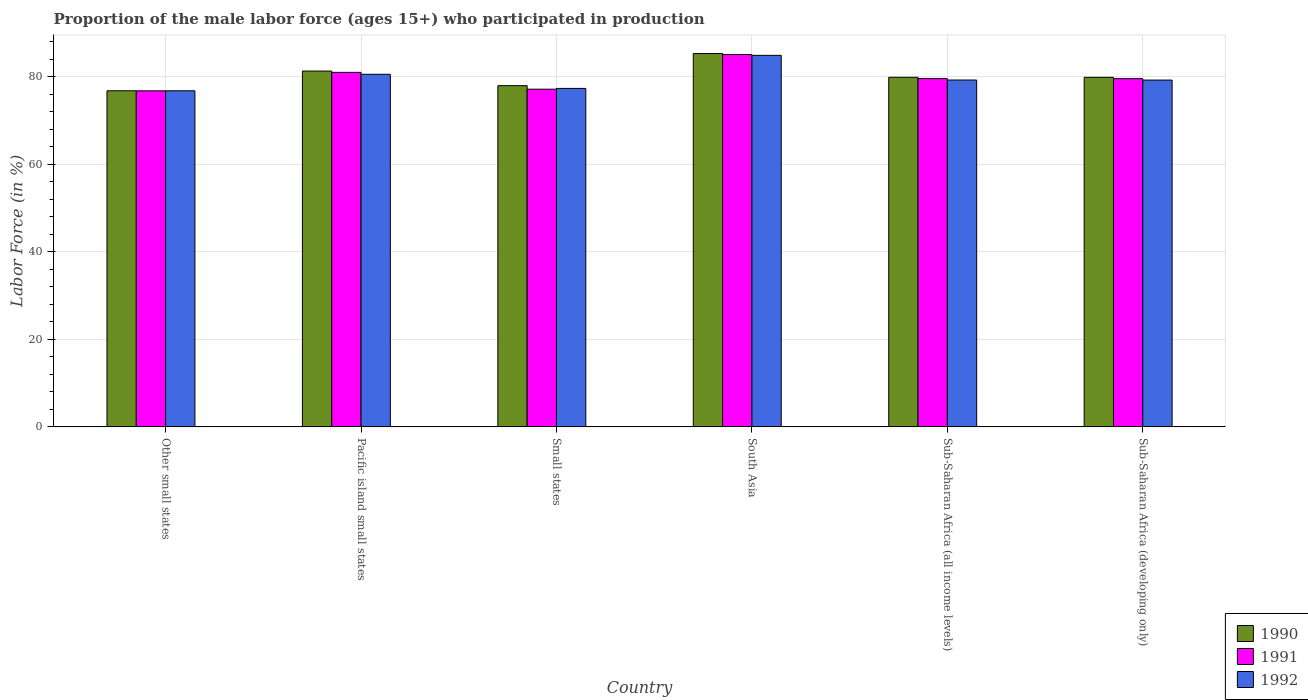How many different coloured bars are there?
Your response must be concise. 3. How many bars are there on the 1st tick from the left?
Your answer should be compact. 3. What is the label of the 3rd group of bars from the left?
Your answer should be very brief. Small states. What is the proportion of the male labor force who participated in production in 1992 in South Asia?
Your answer should be compact. 84.88. Across all countries, what is the maximum proportion of the male labor force who participated in production in 1990?
Keep it short and to the point. 85.3. Across all countries, what is the minimum proportion of the male labor force who participated in production in 1991?
Your answer should be compact. 76.78. In which country was the proportion of the male labor force who participated in production in 1991 maximum?
Give a very brief answer. South Asia. In which country was the proportion of the male labor force who participated in production in 1990 minimum?
Offer a terse response. Other small states. What is the total proportion of the male labor force who participated in production in 1991 in the graph?
Make the answer very short. 479.13. What is the difference between the proportion of the male labor force who participated in production in 1990 in Other small states and that in South Asia?
Provide a short and direct response. -8.51. What is the difference between the proportion of the male labor force who participated in production in 1990 in Other small states and the proportion of the male labor force who participated in production in 1992 in Sub-Saharan Africa (developing only)?
Ensure brevity in your answer.  -2.44. What is the average proportion of the male labor force who participated in production in 1990 per country?
Provide a succinct answer. 80.18. What is the difference between the proportion of the male labor force who participated in production of/in 1991 and proportion of the male labor force who participated in production of/in 1992 in Sub-Saharan Africa (all income levels)?
Provide a short and direct response. 0.32. What is the ratio of the proportion of the male labor force who participated in production in 1990 in South Asia to that in Sub-Saharan Africa (all income levels)?
Provide a short and direct response. 1.07. What is the difference between the highest and the second highest proportion of the male labor force who participated in production in 1991?
Make the answer very short. -4.07. What is the difference between the highest and the lowest proportion of the male labor force who participated in production in 1990?
Your answer should be compact. 8.51. In how many countries, is the proportion of the male labor force who participated in production in 1990 greater than the average proportion of the male labor force who participated in production in 1990 taken over all countries?
Provide a succinct answer. 2. What does the 2nd bar from the left in Sub-Saharan Africa (developing only) represents?
Keep it short and to the point. 1991. Is it the case that in every country, the sum of the proportion of the male labor force who participated in production in 1990 and proportion of the male labor force who participated in production in 1992 is greater than the proportion of the male labor force who participated in production in 1991?
Your response must be concise. Yes. How many bars are there?
Give a very brief answer. 18. Are all the bars in the graph horizontal?
Provide a short and direct response. No. How many countries are there in the graph?
Your response must be concise. 6. Does the graph contain any zero values?
Offer a very short reply. No. Where does the legend appear in the graph?
Keep it short and to the point. Bottom right. How are the legend labels stacked?
Give a very brief answer. Vertical. What is the title of the graph?
Your response must be concise. Proportion of the male labor force (ages 15+) who participated in production. Does "2015" appear as one of the legend labels in the graph?
Offer a terse response. No. What is the label or title of the X-axis?
Ensure brevity in your answer.  Country. What is the Labor Force (in %) of 1990 in Other small states?
Offer a terse response. 76.79. What is the Labor Force (in %) in 1991 in Other small states?
Your answer should be very brief. 76.78. What is the Labor Force (in %) of 1992 in Other small states?
Give a very brief answer. 76.79. What is the Labor Force (in %) in 1990 in Pacific island small states?
Your response must be concise. 81.29. What is the Labor Force (in %) of 1991 in Pacific island small states?
Provide a short and direct response. 81. What is the Labor Force (in %) of 1992 in Pacific island small states?
Make the answer very short. 80.56. What is the Labor Force (in %) in 1990 in Small states?
Make the answer very short. 77.96. What is the Labor Force (in %) of 1991 in Small states?
Make the answer very short. 77.15. What is the Labor Force (in %) of 1992 in Small states?
Provide a short and direct response. 77.33. What is the Labor Force (in %) in 1990 in South Asia?
Your answer should be very brief. 85.3. What is the Labor Force (in %) of 1991 in South Asia?
Provide a succinct answer. 85.07. What is the Labor Force (in %) of 1992 in South Asia?
Provide a short and direct response. 84.88. What is the Labor Force (in %) in 1990 in Sub-Saharan Africa (all income levels)?
Keep it short and to the point. 79.87. What is the Labor Force (in %) in 1991 in Sub-Saharan Africa (all income levels)?
Make the answer very short. 79.57. What is the Labor Force (in %) of 1992 in Sub-Saharan Africa (all income levels)?
Ensure brevity in your answer.  79.25. What is the Labor Force (in %) of 1990 in Sub-Saharan Africa (developing only)?
Make the answer very short. 79.86. What is the Labor Force (in %) of 1991 in Sub-Saharan Africa (developing only)?
Your answer should be very brief. 79.56. What is the Labor Force (in %) in 1992 in Sub-Saharan Africa (developing only)?
Ensure brevity in your answer.  79.23. Across all countries, what is the maximum Labor Force (in %) of 1990?
Your answer should be very brief. 85.3. Across all countries, what is the maximum Labor Force (in %) in 1991?
Make the answer very short. 85.07. Across all countries, what is the maximum Labor Force (in %) of 1992?
Keep it short and to the point. 84.88. Across all countries, what is the minimum Labor Force (in %) of 1990?
Give a very brief answer. 76.79. Across all countries, what is the minimum Labor Force (in %) in 1991?
Make the answer very short. 76.78. Across all countries, what is the minimum Labor Force (in %) in 1992?
Give a very brief answer. 76.79. What is the total Labor Force (in %) in 1990 in the graph?
Offer a terse response. 481.07. What is the total Labor Force (in %) in 1991 in the graph?
Ensure brevity in your answer.  479.13. What is the total Labor Force (in %) of 1992 in the graph?
Your answer should be compact. 478.03. What is the difference between the Labor Force (in %) of 1990 in Other small states and that in Pacific island small states?
Give a very brief answer. -4.5. What is the difference between the Labor Force (in %) in 1991 in Other small states and that in Pacific island small states?
Your answer should be very brief. -4.23. What is the difference between the Labor Force (in %) of 1992 in Other small states and that in Pacific island small states?
Offer a very short reply. -3.77. What is the difference between the Labor Force (in %) of 1990 in Other small states and that in Small states?
Provide a short and direct response. -1.17. What is the difference between the Labor Force (in %) in 1991 in Other small states and that in Small states?
Ensure brevity in your answer.  -0.38. What is the difference between the Labor Force (in %) of 1992 in Other small states and that in Small states?
Your answer should be very brief. -0.54. What is the difference between the Labor Force (in %) in 1990 in Other small states and that in South Asia?
Your response must be concise. -8.51. What is the difference between the Labor Force (in %) of 1991 in Other small states and that in South Asia?
Make the answer very short. -8.3. What is the difference between the Labor Force (in %) in 1992 in Other small states and that in South Asia?
Provide a short and direct response. -8.1. What is the difference between the Labor Force (in %) in 1990 in Other small states and that in Sub-Saharan Africa (all income levels)?
Give a very brief answer. -3.08. What is the difference between the Labor Force (in %) in 1991 in Other small states and that in Sub-Saharan Africa (all income levels)?
Give a very brief answer. -2.79. What is the difference between the Labor Force (in %) of 1992 in Other small states and that in Sub-Saharan Africa (all income levels)?
Your answer should be compact. -2.46. What is the difference between the Labor Force (in %) of 1990 in Other small states and that in Sub-Saharan Africa (developing only)?
Keep it short and to the point. -3.07. What is the difference between the Labor Force (in %) in 1991 in Other small states and that in Sub-Saharan Africa (developing only)?
Give a very brief answer. -2.78. What is the difference between the Labor Force (in %) in 1992 in Other small states and that in Sub-Saharan Africa (developing only)?
Offer a terse response. -2.45. What is the difference between the Labor Force (in %) in 1990 in Pacific island small states and that in Small states?
Make the answer very short. 3.34. What is the difference between the Labor Force (in %) of 1991 in Pacific island small states and that in Small states?
Provide a short and direct response. 3.85. What is the difference between the Labor Force (in %) in 1992 in Pacific island small states and that in Small states?
Offer a very short reply. 3.23. What is the difference between the Labor Force (in %) of 1990 in Pacific island small states and that in South Asia?
Make the answer very short. -4. What is the difference between the Labor Force (in %) of 1991 in Pacific island small states and that in South Asia?
Provide a short and direct response. -4.07. What is the difference between the Labor Force (in %) of 1992 in Pacific island small states and that in South Asia?
Your answer should be compact. -4.33. What is the difference between the Labor Force (in %) in 1990 in Pacific island small states and that in Sub-Saharan Africa (all income levels)?
Offer a very short reply. 1.42. What is the difference between the Labor Force (in %) of 1991 in Pacific island small states and that in Sub-Saharan Africa (all income levels)?
Give a very brief answer. 1.43. What is the difference between the Labor Force (in %) of 1992 in Pacific island small states and that in Sub-Saharan Africa (all income levels)?
Offer a terse response. 1.31. What is the difference between the Labor Force (in %) of 1990 in Pacific island small states and that in Sub-Saharan Africa (developing only)?
Your answer should be very brief. 1.43. What is the difference between the Labor Force (in %) in 1991 in Pacific island small states and that in Sub-Saharan Africa (developing only)?
Your response must be concise. 1.44. What is the difference between the Labor Force (in %) in 1992 in Pacific island small states and that in Sub-Saharan Africa (developing only)?
Keep it short and to the point. 1.32. What is the difference between the Labor Force (in %) of 1990 in Small states and that in South Asia?
Make the answer very short. -7.34. What is the difference between the Labor Force (in %) in 1991 in Small states and that in South Asia?
Your answer should be compact. -7.92. What is the difference between the Labor Force (in %) of 1992 in Small states and that in South Asia?
Ensure brevity in your answer.  -7.56. What is the difference between the Labor Force (in %) in 1990 in Small states and that in Sub-Saharan Africa (all income levels)?
Ensure brevity in your answer.  -1.91. What is the difference between the Labor Force (in %) of 1991 in Small states and that in Sub-Saharan Africa (all income levels)?
Your answer should be very brief. -2.42. What is the difference between the Labor Force (in %) in 1992 in Small states and that in Sub-Saharan Africa (all income levels)?
Your answer should be very brief. -1.92. What is the difference between the Labor Force (in %) in 1990 in Small states and that in Sub-Saharan Africa (developing only)?
Your response must be concise. -1.9. What is the difference between the Labor Force (in %) in 1991 in Small states and that in Sub-Saharan Africa (developing only)?
Keep it short and to the point. -2.41. What is the difference between the Labor Force (in %) in 1992 in Small states and that in Sub-Saharan Africa (developing only)?
Provide a short and direct response. -1.91. What is the difference between the Labor Force (in %) in 1990 in South Asia and that in Sub-Saharan Africa (all income levels)?
Keep it short and to the point. 5.43. What is the difference between the Labor Force (in %) of 1991 in South Asia and that in Sub-Saharan Africa (all income levels)?
Your answer should be compact. 5.5. What is the difference between the Labor Force (in %) in 1992 in South Asia and that in Sub-Saharan Africa (all income levels)?
Offer a very short reply. 5.64. What is the difference between the Labor Force (in %) of 1990 in South Asia and that in Sub-Saharan Africa (developing only)?
Provide a succinct answer. 5.44. What is the difference between the Labor Force (in %) of 1991 in South Asia and that in Sub-Saharan Africa (developing only)?
Give a very brief answer. 5.51. What is the difference between the Labor Force (in %) in 1992 in South Asia and that in Sub-Saharan Africa (developing only)?
Make the answer very short. 5.65. What is the difference between the Labor Force (in %) in 1990 in Sub-Saharan Africa (all income levels) and that in Sub-Saharan Africa (developing only)?
Provide a short and direct response. 0.01. What is the difference between the Labor Force (in %) of 1991 in Sub-Saharan Africa (all income levels) and that in Sub-Saharan Africa (developing only)?
Keep it short and to the point. 0.01. What is the difference between the Labor Force (in %) in 1992 in Sub-Saharan Africa (all income levels) and that in Sub-Saharan Africa (developing only)?
Your answer should be compact. 0.01. What is the difference between the Labor Force (in %) in 1990 in Other small states and the Labor Force (in %) in 1991 in Pacific island small states?
Your answer should be compact. -4.21. What is the difference between the Labor Force (in %) in 1990 in Other small states and the Labor Force (in %) in 1992 in Pacific island small states?
Provide a short and direct response. -3.76. What is the difference between the Labor Force (in %) of 1991 in Other small states and the Labor Force (in %) of 1992 in Pacific island small states?
Your answer should be very brief. -3.78. What is the difference between the Labor Force (in %) of 1990 in Other small states and the Labor Force (in %) of 1991 in Small states?
Offer a terse response. -0.36. What is the difference between the Labor Force (in %) in 1990 in Other small states and the Labor Force (in %) in 1992 in Small states?
Offer a very short reply. -0.54. What is the difference between the Labor Force (in %) in 1991 in Other small states and the Labor Force (in %) in 1992 in Small states?
Ensure brevity in your answer.  -0.55. What is the difference between the Labor Force (in %) in 1990 in Other small states and the Labor Force (in %) in 1991 in South Asia?
Give a very brief answer. -8.28. What is the difference between the Labor Force (in %) in 1990 in Other small states and the Labor Force (in %) in 1992 in South Asia?
Give a very brief answer. -8.09. What is the difference between the Labor Force (in %) of 1991 in Other small states and the Labor Force (in %) of 1992 in South Asia?
Keep it short and to the point. -8.11. What is the difference between the Labor Force (in %) of 1990 in Other small states and the Labor Force (in %) of 1991 in Sub-Saharan Africa (all income levels)?
Provide a succinct answer. -2.78. What is the difference between the Labor Force (in %) in 1990 in Other small states and the Labor Force (in %) in 1992 in Sub-Saharan Africa (all income levels)?
Offer a very short reply. -2.45. What is the difference between the Labor Force (in %) in 1991 in Other small states and the Labor Force (in %) in 1992 in Sub-Saharan Africa (all income levels)?
Your answer should be very brief. -2.47. What is the difference between the Labor Force (in %) in 1990 in Other small states and the Labor Force (in %) in 1991 in Sub-Saharan Africa (developing only)?
Ensure brevity in your answer.  -2.77. What is the difference between the Labor Force (in %) of 1990 in Other small states and the Labor Force (in %) of 1992 in Sub-Saharan Africa (developing only)?
Your answer should be very brief. -2.44. What is the difference between the Labor Force (in %) in 1991 in Other small states and the Labor Force (in %) in 1992 in Sub-Saharan Africa (developing only)?
Provide a short and direct response. -2.46. What is the difference between the Labor Force (in %) of 1990 in Pacific island small states and the Labor Force (in %) of 1991 in Small states?
Keep it short and to the point. 4.14. What is the difference between the Labor Force (in %) of 1990 in Pacific island small states and the Labor Force (in %) of 1992 in Small states?
Offer a terse response. 3.97. What is the difference between the Labor Force (in %) of 1991 in Pacific island small states and the Labor Force (in %) of 1992 in Small states?
Your response must be concise. 3.67. What is the difference between the Labor Force (in %) in 1990 in Pacific island small states and the Labor Force (in %) in 1991 in South Asia?
Offer a terse response. -3.78. What is the difference between the Labor Force (in %) of 1990 in Pacific island small states and the Labor Force (in %) of 1992 in South Asia?
Your answer should be very brief. -3.59. What is the difference between the Labor Force (in %) of 1991 in Pacific island small states and the Labor Force (in %) of 1992 in South Asia?
Make the answer very short. -3.88. What is the difference between the Labor Force (in %) in 1990 in Pacific island small states and the Labor Force (in %) in 1991 in Sub-Saharan Africa (all income levels)?
Your answer should be compact. 1.72. What is the difference between the Labor Force (in %) in 1990 in Pacific island small states and the Labor Force (in %) in 1992 in Sub-Saharan Africa (all income levels)?
Offer a terse response. 2.05. What is the difference between the Labor Force (in %) in 1991 in Pacific island small states and the Labor Force (in %) in 1992 in Sub-Saharan Africa (all income levels)?
Make the answer very short. 1.76. What is the difference between the Labor Force (in %) in 1990 in Pacific island small states and the Labor Force (in %) in 1991 in Sub-Saharan Africa (developing only)?
Offer a very short reply. 1.74. What is the difference between the Labor Force (in %) in 1990 in Pacific island small states and the Labor Force (in %) in 1992 in Sub-Saharan Africa (developing only)?
Make the answer very short. 2.06. What is the difference between the Labor Force (in %) in 1991 in Pacific island small states and the Labor Force (in %) in 1992 in Sub-Saharan Africa (developing only)?
Ensure brevity in your answer.  1.77. What is the difference between the Labor Force (in %) in 1990 in Small states and the Labor Force (in %) in 1991 in South Asia?
Offer a very short reply. -7.11. What is the difference between the Labor Force (in %) in 1990 in Small states and the Labor Force (in %) in 1992 in South Asia?
Offer a very short reply. -6.93. What is the difference between the Labor Force (in %) in 1991 in Small states and the Labor Force (in %) in 1992 in South Asia?
Make the answer very short. -7.73. What is the difference between the Labor Force (in %) in 1990 in Small states and the Labor Force (in %) in 1991 in Sub-Saharan Africa (all income levels)?
Ensure brevity in your answer.  -1.61. What is the difference between the Labor Force (in %) of 1990 in Small states and the Labor Force (in %) of 1992 in Sub-Saharan Africa (all income levels)?
Your response must be concise. -1.29. What is the difference between the Labor Force (in %) in 1991 in Small states and the Labor Force (in %) in 1992 in Sub-Saharan Africa (all income levels)?
Give a very brief answer. -2.09. What is the difference between the Labor Force (in %) in 1990 in Small states and the Labor Force (in %) in 1991 in Sub-Saharan Africa (developing only)?
Offer a terse response. -1.6. What is the difference between the Labor Force (in %) in 1990 in Small states and the Labor Force (in %) in 1992 in Sub-Saharan Africa (developing only)?
Offer a terse response. -1.28. What is the difference between the Labor Force (in %) of 1991 in Small states and the Labor Force (in %) of 1992 in Sub-Saharan Africa (developing only)?
Your answer should be compact. -2.08. What is the difference between the Labor Force (in %) in 1990 in South Asia and the Labor Force (in %) in 1991 in Sub-Saharan Africa (all income levels)?
Offer a very short reply. 5.73. What is the difference between the Labor Force (in %) of 1990 in South Asia and the Labor Force (in %) of 1992 in Sub-Saharan Africa (all income levels)?
Offer a very short reply. 6.05. What is the difference between the Labor Force (in %) in 1991 in South Asia and the Labor Force (in %) in 1992 in Sub-Saharan Africa (all income levels)?
Your answer should be compact. 5.83. What is the difference between the Labor Force (in %) of 1990 in South Asia and the Labor Force (in %) of 1991 in Sub-Saharan Africa (developing only)?
Your response must be concise. 5.74. What is the difference between the Labor Force (in %) of 1990 in South Asia and the Labor Force (in %) of 1992 in Sub-Saharan Africa (developing only)?
Your response must be concise. 6.06. What is the difference between the Labor Force (in %) in 1991 in South Asia and the Labor Force (in %) in 1992 in Sub-Saharan Africa (developing only)?
Your answer should be very brief. 5.84. What is the difference between the Labor Force (in %) of 1990 in Sub-Saharan Africa (all income levels) and the Labor Force (in %) of 1991 in Sub-Saharan Africa (developing only)?
Offer a very short reply. 0.31. What is the difference between the Labor Force (in %) in 1990 in Sub-Saharan Africa (all income levels) and the Labor Force (in %) in 1992 in Sub-Saharan Africa (developing only)?
Make the answer very short. 0.64. What is the difference between the Labor Force (in %) in 1991 in Sub-Saharan Africa (all income levels) and the Labor Force (in %) in 1992 in Sub-Saharan Africa (developing only)?
Your answer should be compact. 0.34. What is the average Labor Force (in %) of 1990 per country?
Give a very brief answer. 80.18. What is the average Labor Force (in %) in 1991 per country?
Ensure brevity in your answer.  79.85. What is the average Labor Force (in %) in 1992 per country?
Your answer should be compact. 79.67. What is the difference between the Labor Force (in %) in 1990 and Labor Force (in %) in 1991 in Other small states?
Provide a short and direct response. 0.02. What is the difference between the Labor Force (in %) of 1990 and Labor Force (in %) of 1992 in Other small states?
Offer a very short reply. 0. What is the difference between the Labor Force (in %) in 1991 and Labor Force (in %) in 1992 in Other small states?
Offer a terse response. -0.01. What is the difference between the Labor Force (in %) of 1990 and Labor Force (in %) of 1991 in Pacific island small states?
Provide a short and direct response. 0.29. What is the difference between the Labor Force (in %) in 1990 and Labor Force (in %) in 1992 in Pacific island small states?
Provide a succinct answer. 0.74. What is the difference between the Labor Force (in %) of 1991 and Labor Force (in %) of 1992 in Pacific island small states?
Provide a succinct answer. 0.44. What is the difference between the Labor Force (in %) of 1990 and Labor Force (in %) of 1991 in Small states?
Offer a very short reply. 0.81. What is the difference between the Labor Force (in %) in 1990 and Labor Force (in %) in 1992 in Small states?
Ensure brevity in your answer.  0.63. What is the difference between the Labor Force (in %) of 1991 and Labor Force (in %) of 1992 in Small states?
Make the answer very short. -0.18. What is the difference between the Labor Force (in %) in 1990 and Labor Force (in %) in 1991 in South Asia?
Offer a very short reply. 0.23. What is the difference between the Labor Force (in %) in 1990 and Labor Force (in %) in 1992 in South Asia?
Offer a very short reply. 0.41. What is the difference between the Labor Force (in %) of 1991 and Labor Force (in %) of 1992 in South Asia?
Ensure brevity in your answer.  0.19. What is the difference between the Labor Force (in %) in 1990 and Labor Force (in %) in 1991 in Sub-Saharan Africa (all income levels)?
Provide a succinct answer. 0.3. What is the difference between the Labor Force (in %) in 1990 and Labor Force (in %) in 1992 in Sub-Saharan Africa (all income levels)?
Your answer should be compact. 0.63. What is the difference between the Labor Force (in %) of 1991 and Labor Force (in %) of 1992 in Sub-Saharan Africa (all income levels)?
Give a very brief answer. 0.32. What is the difference between the Labor Force (in %) of 1990 and Labor Force (in %) of 1991 in Sub-Saharan Africa (developing only)?
Ensure brevity in your answer.  0.3. What is the difference between the Labor Force (in %) of 1990 and Labor Force (in %) of 1992 in Sub-Saharan Africa (developing only)?
Offer a very short reply. 0.63. What is the difference between the Labor Force (in %) in 1991 and Labor Force (in %) in 1992 in Sub-Saharan Africa (developing only)?
Offer a terse response. 0.33. What is the ratio of the Labor Force (in %) of 1990 in Other small states to that in Pacific island small states?
Ensure brevity in your answer.  0.94. What is the ratio of the Labor Force (in %) in 1991 in Other small states to that in Pacific island small states?
Your answer should be compact. 0.95. What is the ratio of the Labor Force (in %) of 1992 in Other small states to that in Pacific island small states?
Provide a short and direct response. 0.95. What is the ratio of the Labor Force (in %) of 1991 in Other small states to that in Small states?
Offer a terse response. 1. What is the ratio of the Labor Force (in %) of 1992 in Other small states to that in Small states?
Your answer should be very brief. 0.99. What is the ratio of the Labor Force (in %) of 1990 in Other small states to that in South Asia?
Your answer should be very brief. 0.9. What is the ratio of the Labor Force (in %) of 1991 in Other small states to that in South Asia?
Provide a succinct answer. 0.9. What is the ratio of the Labor Force (in %) in 1992 in Other small states to that in South Asia?
Offer a very short reply. 0.9. What is the ratio of the Labor Force (in %) in 1990 in Other small states to that in Sub-Saharan Africa (all income levels)?
Your answer should be very brief. 0.96. What is the ratio of the Labor Force (in %) of 1991 in Other small states to that in Sub-Saharan Africa (all income levels)?
Provide a short and direct response. 0.96. What is the ratio of the Labor Force (in %) in 1990 in Other small states to that in Sub-Saharan Africa (developing only)?
Your response must be concise. 0.96. What is the ratio of the Labor Force (in %) in 1992 in Other small states to that in Sub-Saharan Africa (developing only)?
Provide a succinct answer. 0.97. What is the ratio of the Labor Force (in %) of 1990 in Pacific island small states to that in Small states?
Your response must be concise. 1.04. What is the ratio of the Labor Force (in %) of 1991 in Pacific island small states to that in Small states?
Offer a very short reply. 1.05. What is the ratio of the Labor Force (in %) in 1992 in Pacific island small states to that in Small states?
Provide a succinct answer. 1.04. What is the ratio of the Labor Force (in %) of 1990 in Pacific island small states to that in South Asia?
Your answer should be very brief. 0.95. What is the ratio of the Labor Force (in %) of 1991 in Pacific island small states to that in South Asia?
Your answer should be compact. 0.95. What is the ratio of the Labor Force (in %) of 1992 in Pacific island small states to that in South Asia?
Provide a succinct answer. 0.95. What is the ratio of the Labor Force (in %) of 1990 in Pacific island small states to that in Sub-Saharan Africa (all income levels)?
Ensure brevity in your answer.  1.02. What is the ratio of the Labor Force (in %) of 1992 in Pacific island small states to that in Sub-Saharan Africa (all income levels)?
Your answer should be compact. 1.02. What is the ratio of the Labor Force (in %) of 1990 in Pacific island small states to that in Sub-Saharan Africa (developing only)?
Make the answer very short. 1.02. What is the ratio of the Labor Force (in %) of 1991 in Pacific island small states to that in Sub-Saharan Africa (developing only)?
Provide a short and direct response. 1.02. What is the ratio of the Labor Force (in %) of 1992 in Pacific island small states to that in Sub-Saharan Africa (developing only)?
Make the answer very short. 1.02. What is the ratio of the Labor Force (in %) of 1990 in Small states to that in South Asia?
Provide a succinct answer. 0.91. What is the ratio of the Labor Force (in %) of 1991 in Small states to that in South Asia?
Your response must be concise. 0.91. What is the ratio of the Labor Force (in %) in 1992 in Small states to that in South Asia?
Provide a short and direct response. 0.91. What is the ratio of the Labor Force (in %) in 1990 in Small states to that in Sub-Saharan Africa (all income levels)?
Provide a short and direct response. 0.98. What is the ratio of the Labor Force (in %) of 1991 in Small states to that in Sub-Saharan Africa (all income levels)?
Provide a succinct answer. 0.97. What is the ratio of the Labor Force (in %) in 1992 in Small states to that in Sub-Saharan Africa (all income levels)?
Your answer should be very brief. 0.98. What is the ratio of the Labor Force (in %) of 1990 in Small states to that in Sub-Saharan Africa (developing only)?
Your answer should be very brief. 0.98. What is the ratio of the Labor Force (in %) of 1991 in Small states to that in Sub-Saharan Africa (developing only)?
Provide a short and direct response. 0.97. What is the ratio of the Labor Force (in %) of 1990 in South Asia to that in Sub-Saharan Africa (all income levels)?
Offer a terse response. 1.07. What is the ratio of the Labor Force (in %) of 1991 in South Asia to that in Sub-Saharan Africa (all income levels)?
Provide a succinct answer. 1.07. What is the ratio of the Labor Force (in %) in 1992 in South Asia to that in Sub-Saharan Africa (all income levels)?
Make the answer very short. 1.07. What is the ratio of the Labor Force (in %) of 1990 in South Asia to that in Sub-Saharan Africa (developing only)?
Give a very brief answer. 1.07. What is the ratio of the Labor Force (in %) of 1991 in South Asia to that in Sub-Saharan Africa (developing only)?
Keep it short and to the point. 1.07. What is the ratio of the Labor Force (in %) in 1992 in South Asia to that in Sub-Saharan Africa (developing only)?
Provide a short and direct response. 1.07. What is the ratio of the Labor Force (in %) of 1991 in Sub-Saharan Africa (all income levels) to that in Sub-Saharan Africa (developing only)?
Ensure brevity in your answer.  1. What is the ratio of the Labor Force (in %) of 1992 in Sub-Saharan Africa (all income levels) to that in Sub-Saharan Africa (developing only)?
Provide a succinct answer. 1. What is the difference between the highest and the second highest Labor Force (in %) in 1990?
Your answer should be very brief. 4. What is the difference between the highest and the second highest Labor Force (in %) in 1991?
Provide a short and direct response. 4.07. What is the difference between the highest and the second highest Labor Force (in %) of 1992?
Provide a succinct answer. 4.33. What is the difference between the highest and the lowest Labor Force (in %) of 1990?
Give a very brief answer. 8.51. What is the difference between the highest and the lowest Labor Force (in %) in 1991?
Make the answer very short. 8.3. What is the difference between the highest and the lowest Labor Force (in %) of 1992?
Provide a short and direct response. 8.1. 